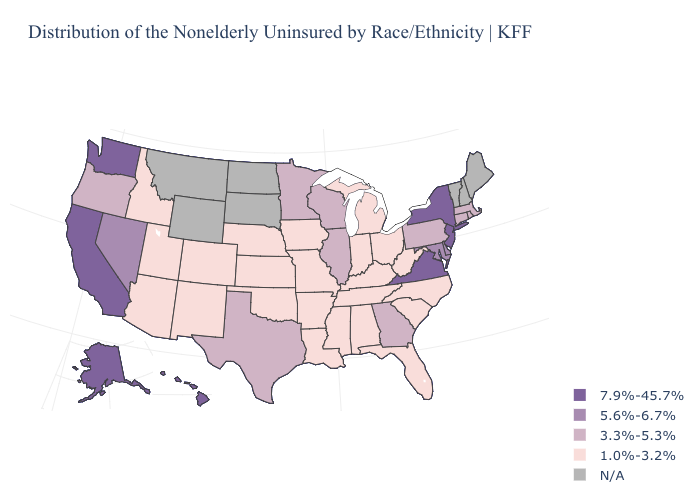Which states have the lowest value in the USA?
Quick response, please. Alabama, Arizona, Arkansas, Colorado, Florida, Idaho, Indiana, Iowa, Kansas, Kentucky, Louisiana, Michigan, Mississippi, Missouri, Nebraska, New Mexico, North Carolina, Ohio, Oklahoma, South Carolina, Tennessee, Utah, West Virginia. What is the value of Alabama?
Short answer required. 1.0%-3.2%. Which states have the highest value in the USA?
Give a very brief answer. Alaska, California, Hawaii, New Jersey, New York, Virginia, Washington. What is the highest value in the South ?
Short answer required. 7.9%-45.7%. What is the value of New York?
Concise answer only. 7.9%-45.7%. What is the highest value in the USA?
Write a very short answer. 7.9%-45.7%. Among the states that border Arizona , does Utah have the highest value?
Concise answer only. No. Which states have the lowest value in the USA?
Answer briefly. Alabama, Arizona, Arkansas, Colorado, Florida, Idaho, Indiana, Iowa, Kansas, Kentucky, Louisiana, Michigan, Mississippi, Missouri, Nebraska, New Mexico, North Carolina, Ohio, Oklahoma, South Carolina, Tennessee, Utah, West Virginia. Does the map have missing data?
Concise answer only. Yes. Name the states that have a value in the range 1.0%-3.2%?
Short answer required. Alabama, Arizona, Arkansas, Colorado, Florida, Idaho, Indiana, Iowa, Kansas, Kentucky, Louisiana, Michigan, Mississippi, Missouri, Nebraska, New Mexico, North Carolina, Ohio, Oklahoma, South Carolina, Tennessee, Utah, West Virginia. Name the states that have a value in the range 7.9%-45.7%?
Short answer required. Alaska, California, Hawaii, New Jersey, New York, Virginia, Washington. What is the lowest value in the Northeast?
Answer briefly. 3.3%-5.3%. What is the value of Iowa?
Quick response, please. 1.0%-3.2%. 